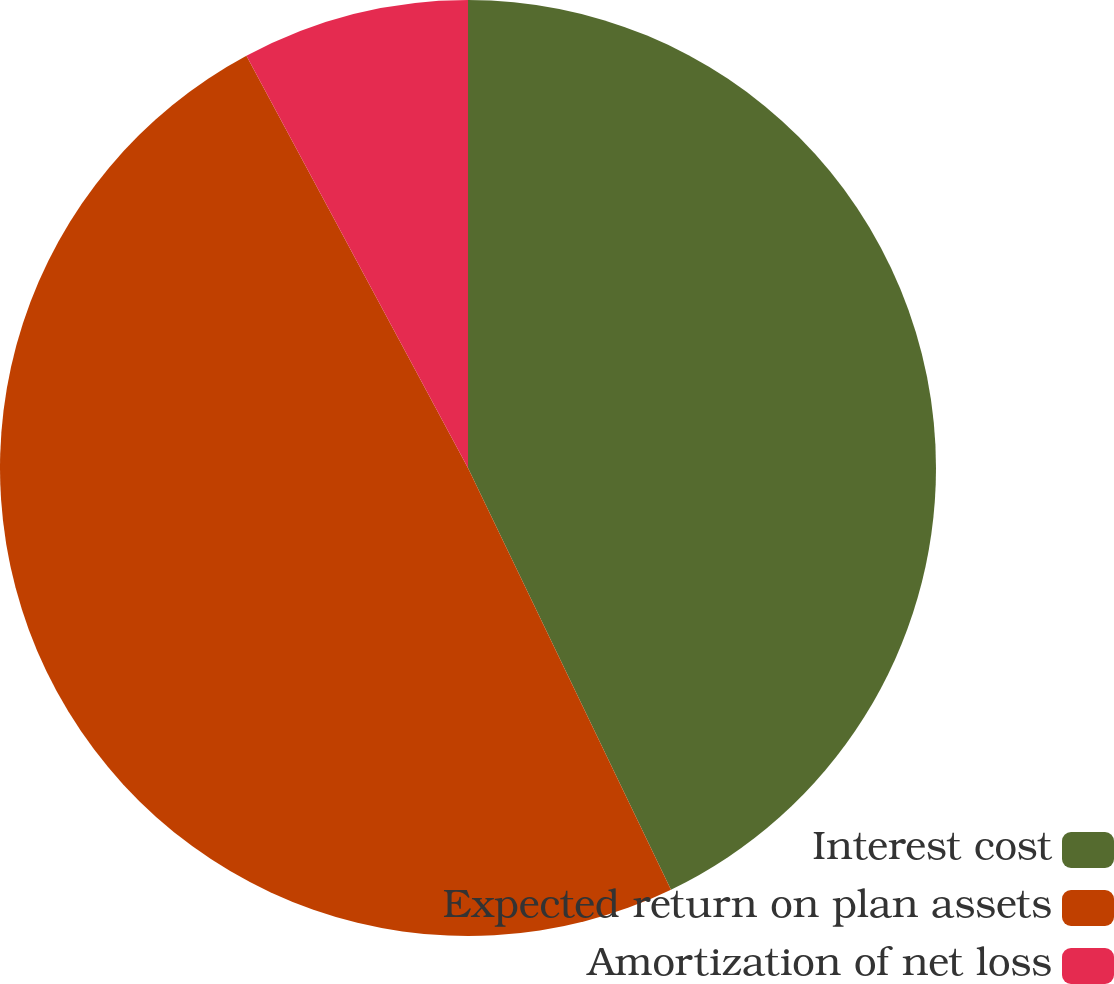Convert chart to OTSL. <chart><loc_0><loc_0><loc_500><loc_500><pie_chart><fcel>Interest cost<fcel>Expected return on plan assets<fcel>Amortization of net loss<nl><fcel>42.86%<fcel>49.29%<fcel>7.85%<nl></chart> 